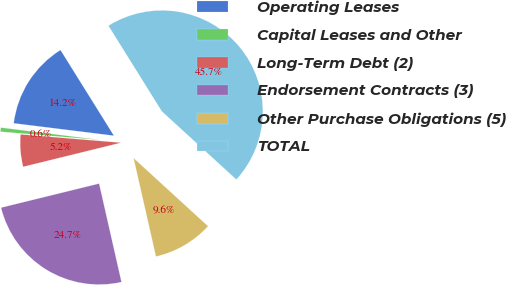Convert chart. <chart><loc_0><loc_0><loc_500><loc_500><pie_chart><fcel>Operating Leases<fcel>Capital Leases and Other<fcel>Long-Term Debt (2)<fcel>Endorsement Contracts (3)<fcel>Other Purchase Obligations (5)<fcel>TOTAL<nl><fcel>14.16%<fcel>0.65%<fcel>5.15%<fcel>24.72%<fcel>9.65%<fcel>45.67%<nl></chart> 